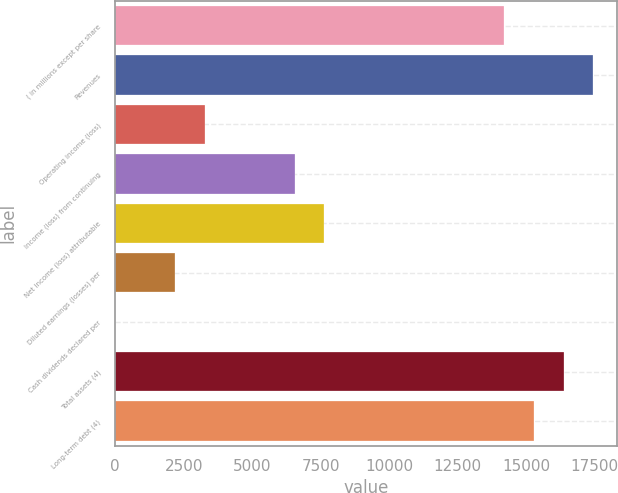<chart> <loc_0><loc_0><loc_500><loc_500><bar_chart><fcel>( in millions except per share<fcel>Revenues<fcel>Operating income (loss)<fcel>Income (loss) from continuing<fcel>Net income (loss) attributable<fcel>Diluted earnings (losses) per<fcel>Cash dividends declared per<fcel>Total assets (4)<fcel>Long-term debt (4)<nl><fcel>14180.4<fcel>17452.7<fcel>3272.46<fcel>6544.83<fcel>7635.62<fcel>2181.67<fcel>0.09<fcel>16361.9<fcel>15271.1<nl></chart> 